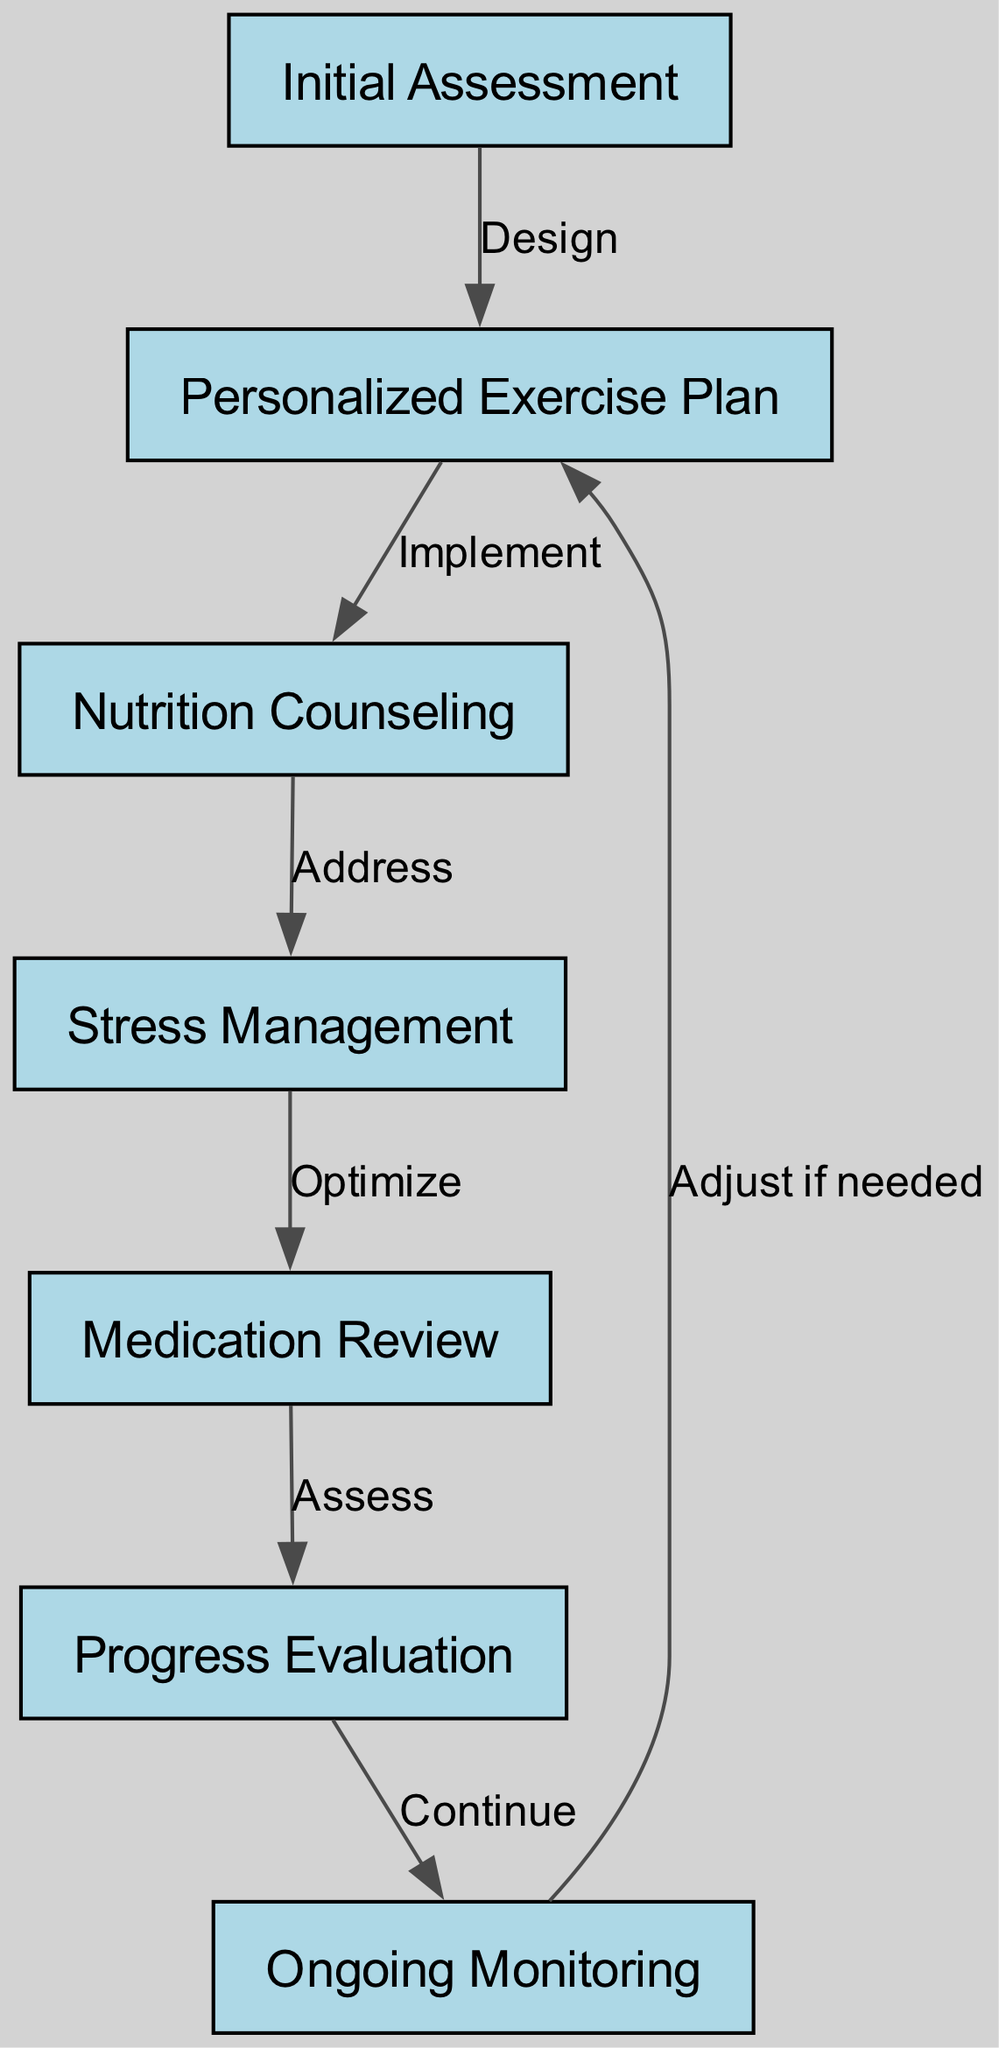What is the first step in the cardiac rehabilitation program? The diagram indicates that the first step in the cardiac rehabilitation program is the "Initial Assessment," as depicted by the first node in the flow chart.
Answer: Initial Assessment How many nodes are present in the diagram? By counting each distinct entity represented in the flow chart, we find there are seven nodes listed, each corresponding to an essential step in the rehabilitation process.
Answer: 7 What comes after "Stress Management"? Following "Stress Management" in the flow chart, the next step is "Medication Review," as indicated by the directed edge from the former to the latter.
Answer: Medication Review What action is associated with the edge from "Nutrition Counseling" to "Stress Management"? The relationship represented by the edge connecting "Nutrition Counseling" to "Stress Management" is labeled "Address," indicating that in this part of the flow, the approach is to address stress-related issues following nutritional guidance.
Answer: Address What is the last step before ongoing monitoring? The last step before "Ongoing Monitoring" is "Progress Evaluation," as denoted by the directed edge leading from "Progress Evaluation" to "Ongoing Monitoring" in the diagram.
Answer: Progress Evaluation How many edges are in the diagram? Each connection represented between nodes is considered an edge. By counting these connections, we find that there are six edges in the flow chart.
Answer: 6 What is the relationship between "Ongoing Monitoring" and "Personalized Exercise Plan"? The flow chart shows that the edge from "Ongoing Monitoring" back to "Personalized Exercise Plan" is labeled "Adjust if needed," indicating that ongoing monitoring may lead to adjustments in the exercise plan based on the patient’s progress.
Answer: Adjust if needed What step directly follows "Medication Review"? The step that directly follows "Medication Review" is "Progress Evaluation," as specified by the direct connection in the flow chart leading to this next stage.
Answer: Progress Evaluation 